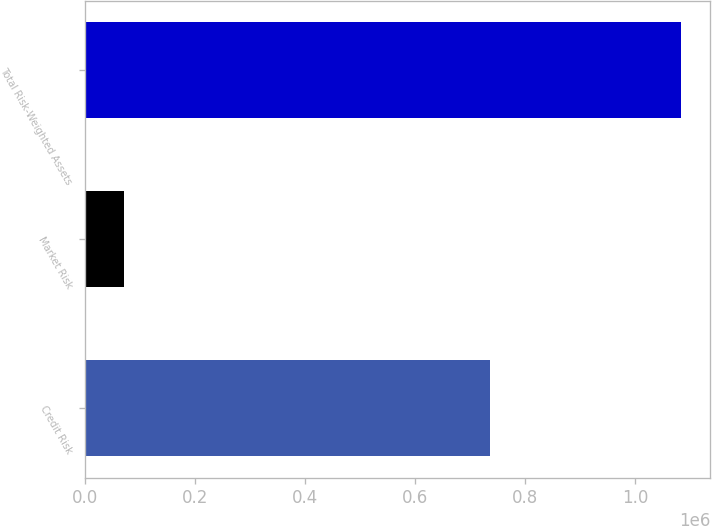Convert chart. <chart><loc_0><loc_0><loc_500><loc_500><bar_chart><fcel>Credit Risk<fcel>Market Risk<fcel>Total Risk-Weighted Assets<nl><fcel>736641<fcel>70715<fcel>1.08328e+06<nl></chart> 